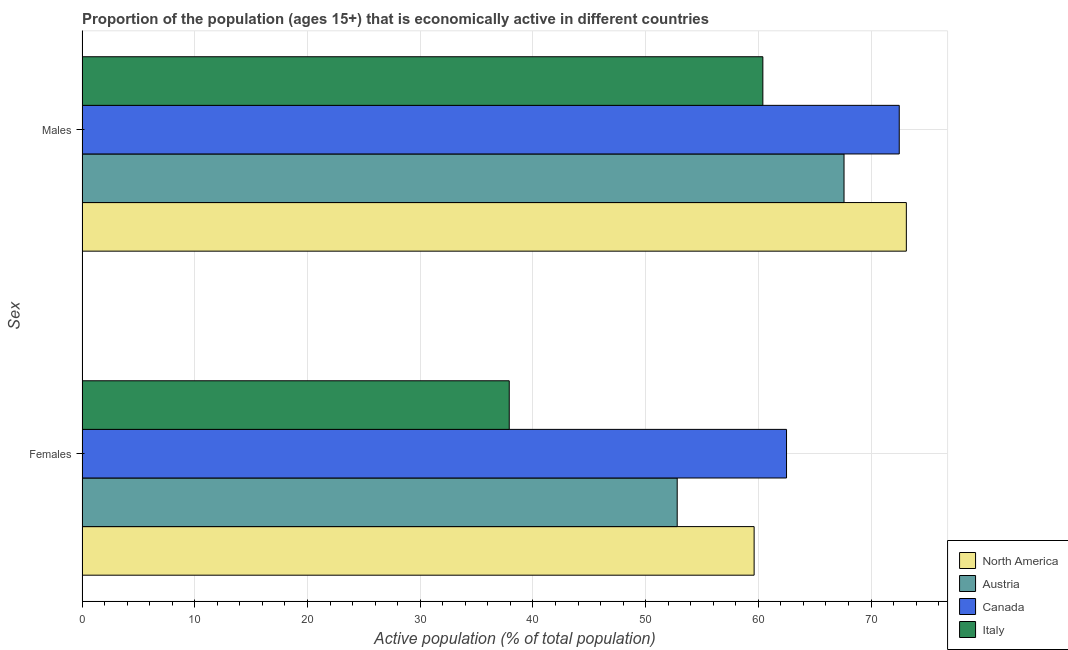How many different coloured bars are there?
Provide a succinct answer. 4. How many groups of bars are there?
Ensure brevity in your answer.  2. Are the number of bars on each tick of the Y-axis equal?
Make the answer very short. Yes. What is the label of the 1st group of bars from the top?
Your response must be concise. Males. What is the percentage of economically active female population in North America?
Your answer should be very brief. 59.62. Across all countries, what is the maximum percentage of economically active female population?
Provide a short and direct response. 62.5. Across all countries, what is the minimum percentage of economically active male population?
Your answer should be very brief. 60.4. What is the total percentage of economically active male population in the graph?
Provide a succinct answer. 273.63. What is the difference between the percentage of economically active female population in Italy and that in North America?
Ensure brevity in your answer.  -21.72. What is the difference between the percentage of economically active female population in Canada and the percentage of economically active male population in Austria?
Give a very brief answer. -5.1. What is the average percentage of economically active male population per country?
Provide a short and direct response. 68.41. What is the difference between the percentage of economically active male population and percentage of economically active female population in North America?
Provide a succinct answer. 13.5. What is the ratio of the percentage of economically active male population in Canada to that in Austria?
Give a very brief answer. 1.07. Is the percentage of economically active female population in Canada less than that in Italy?
Your answer should be very brief. No. In how many countries, is the percentage of economically active male population greater than the average percentage of economically active male population taken over all countries?
Provide a short and direct response. 2. What does the 2nd bar from the bottom in Males represents?
Provide a short and direct response. Austria. How many bars are there?
Offer a terse response. 8. Are all the bars in the graph horizontal?
Offer a terse response. Yes. Does the graph contain any zero values?
Your response must be concise. No. Does the graph contain grids?
Ensure brevity in your answer.  Yes. Where does the legend appear in the graph?
Ensure brevity in your answer.  Bottom right. What is the title of the graph?
Your response must be concise. Proportion of the population (ages 15+) that is economically active in different countries. What is the label or title of the X-axis?
Keep it short and to the point. Active population (% of total population). What is the label or title of the Y-axis?
Keep it short and to the point. Sex. What is the Active population (% of total population) of North America in Females?
Offer a very short reply. 59.62. What is the Active population (% of total population) in Austria in Females?
Provide a succinct answer. 52.8. What is the Active population (% of total population) in Canada in Females?
Offer a terse response. 62.5. What is the Active population (% of total population) in Italy in Females?
Make the answer very short. 37.9. What is the Active population (% of total population) of North America in Males?
Provide a succinct answer. 73.13. What is the Active population (% of total population) of Austria in Males?
Keep it short and to the point. 67.6. What is the Active population (% of total population) in Canada in Males?
Your answer should be very brief. 72.5. What is the Active population (% of total population) in Italy in Males?
Give a very brief answer. 60.4. Across all Sex, what is the maximum Active population (% of total population) of North America?
Give a very brief answer. 73.13. Across all Sex, what is the maximum Active population (% of total population) of Austria?
Offer a terse response. 67.6. Across all Sex, what is the maximum Active population (% of total population) of Canada?
Provide a short and direct response. 72.5. Across all Sex, what is the maximum Active population (% of total population) of Italy?
Your answer should be compact. 60.4. Across all Sex, what is the minimum Active population (% of total population) of North America?
Your answer should be compact. 59.62. Across all Sex, what is the minimum Active population (% of total population) in Austria?
Your answer should be very brief. 52.8. Across all Sex, what is the minimum Active population (% of total population) in Canada?
Offer a very short reply. 62.5. Across all Sex, what is the minimum Active population (% of total population) in Italy?
Offer a very short reply. 37.9. What is the total Active population (% of total population) in North America in the graph?
Your response must be concise. 132.75. What is the total Active population (% of total population) in Austria in the graph?
Make the answer very short. 120.4. What is the total Active population (% of total population) of Canada in the graph?
Keep it short and to the point. 135. What is the total Active population (% of total population) in Italy in the graph?
Your answer should be compact. 98.3. What is the difference between the Active population (% of total population) of North America in Females and that in Males?
Provide a succinct answer. -13.5. What is the difference between the Active population (% of total population) of Austria in Females and that in Males?
Provide a succinct answer. -14.8. What is the difference between the Active population (% of total population) in Italy in Females and that in Males?
Make the answer very short. -22.5. What is the difference between the Active population (% of total population) in North America in Females and the Active population (% of total population) in Austria in Males?
Provide a short and direct response. -7.98. What is the difference between the Active population (% of total population) in North America in Females and the Active population (% of total population) in Canada in Males?
Give a very brief answer. -12.88. What is the difference between the Active population (% of total population) of North America in Females and the Active population (% of total population) of Italy in Males?
Make the answer very short. -0.78. What is the difference between the Active population (% of total population) in Austria in Females and the Active population (% of total population) in Canada in Males?
Ensure brevity in your answer.  -19.7. What is the difference between the Active population (% of total population) in Canada in Females and the Active population (% of total population) in Italy in Males?
Your response must be concise. 2.1. What is the average Active population (% of total population) of North America per Sex?
Provide a succinct answer. 66.38. What is the average Active population (% of total population) of Austria per Sex?
Give a very brief answer. 60.2. What is the average Active population (% of total population) in Canada per Sex?
Keep it short and to the point. 67.5. What is the average Active population (% of total population) in Italy per Sex?
Offer a very short reply. 49.15. What is the difference between the Active population (% of total population) in North America and Active population (% of total population) in Austria in Females?
Provide a short and direct response. 6.82. What is the difference between the Active population (% of total population) of North America and Active population (% of total population) of Canada in Females?
Your answer should be very brief. -2.88. What is the difference between the Active population (% of total population) in North America and Active population (% of total population) in Italy in Females?
Offer a very short reply. 21.72. What is the difference between the Active population (% of total population) of Austria and Active population (% of total population) of Italy in Females?
Keep it short and to the point. 14.9. What is the difference between the Active population (% of total population) in Canada and Active population (% of total population) in Italy in Females?
Offer a terse response. 24.6. What is the difference between the Active population (% of total population) of North America and Active population (% of total population) of Austria in Males?
Provide a short and direct response. 5.53. What is the difference between the Active population (% of total population) in North America and Active population (% of total population) in Canada in Males?
Give a very brief answer. 0.63. What is the difference between the Active population (% of total population) of North America and Active population (% of total population) of Italy in Males?
Your answer should be compact. 12.73. What is the difference between the Active population (% of total population) of Austria and Active population (% of total population) of Canada in Males?
Offer a very short reply. -4.9. What is the ratio of the Active population (% of total population) of North America in Females to that in Males?
Keep it short and to the point. 0.82. What is the ratio of the Active population (% of total population) in Austria in Females to that in Males?
Keep it short and to the point. 0.78. What is the ratio of the Active population (% of total population) in Canada in Females to that in Males?
Offer a terse response. 0.86. What is the ratio of the Active population (% of total population) of Italy in Females to that in Males?
Make the answer very short. 0.63. What is the difference between the highest and the second highest Active population (% of total population) in North America?
Offer a very short reply. 13.5. What is the difference between the highest and the lowest Active population (% of total population) in North America?
Offer a very short reply. 13.5. What is the difference between the highest and the lowest Active population (% of total population) of Canada?
Give a very brief answer. 10. What is the difference between the highest and the lowest Active population (% of total population) in Italy?
Offer a very short reply. 22.5. 